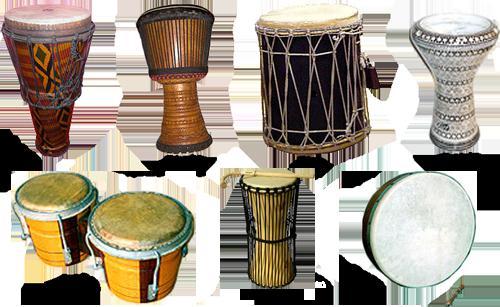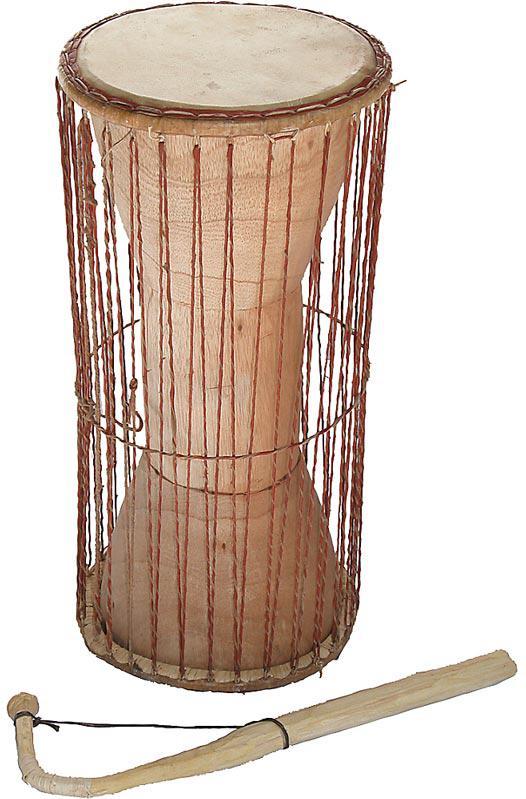The first image is the image on the left, the second image is the image on the right. Examine the images to the left and right. Is the description "There are more drums in the image on the left." accurate? Answer yes or no. Yes. The first image is the image on the left, the second image is the image on the right. Assess this claim about the two images: "there is at least one drum on a platform with wheels". Correct or not? Answer yes or no. No. 